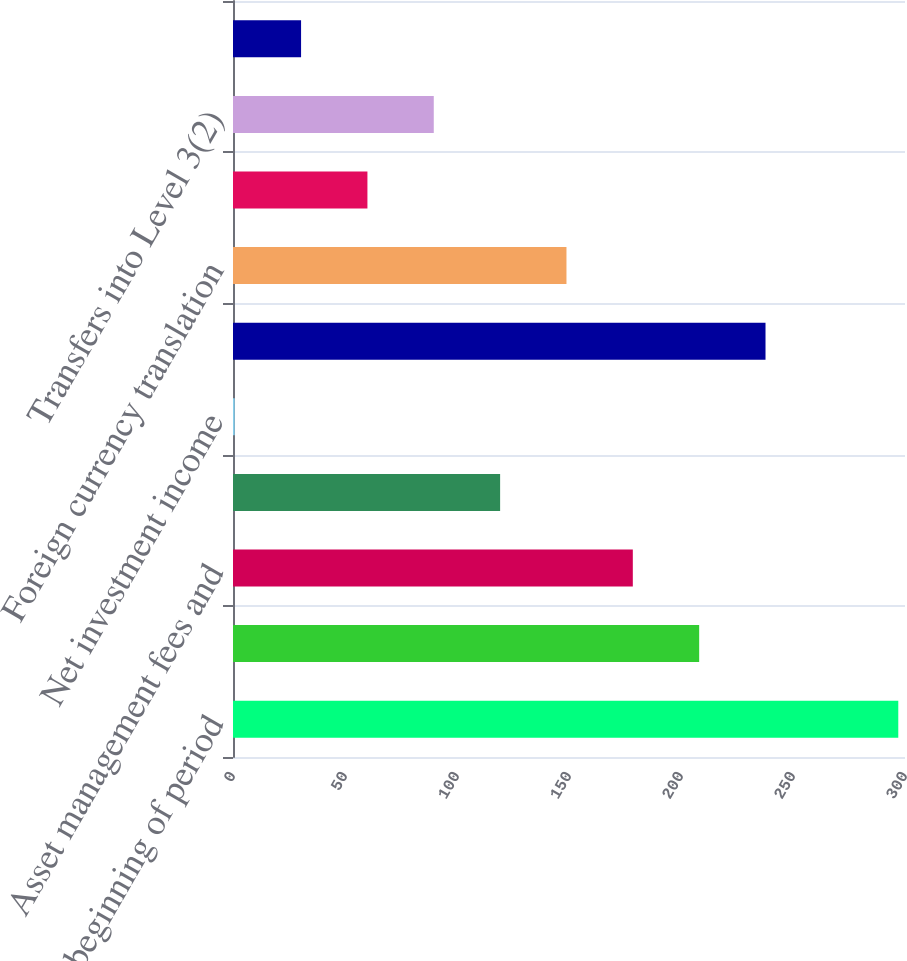Convert chart. <chart><loc_0><loc_0><loc_500><loc_500><bar_chart><fcel>Fair Value beginning of period<fcel>Realized investment gains<fcel>Asset management fees and<fcel>Included in other<fcel>Net investment income<fcel>Purchases sales issuances and<fcel>Foreign currency translation<fcel>Other(1)<fcel>Transfers into Level 3(2)<fcel>Transfers out of Level 3(2)<nl><fcel>297<fcel>208.11<fcel>178.49<fcel>119.25<fcel>0.77<fcel>237.73<fcel>148.87<fcel>60.01<fcel>89.63<fcel>30.39<nl></chart> 